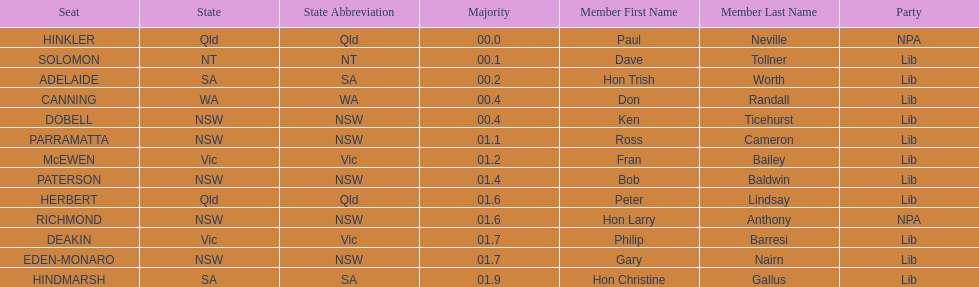Tell me the number of seats from nsw? 5. 